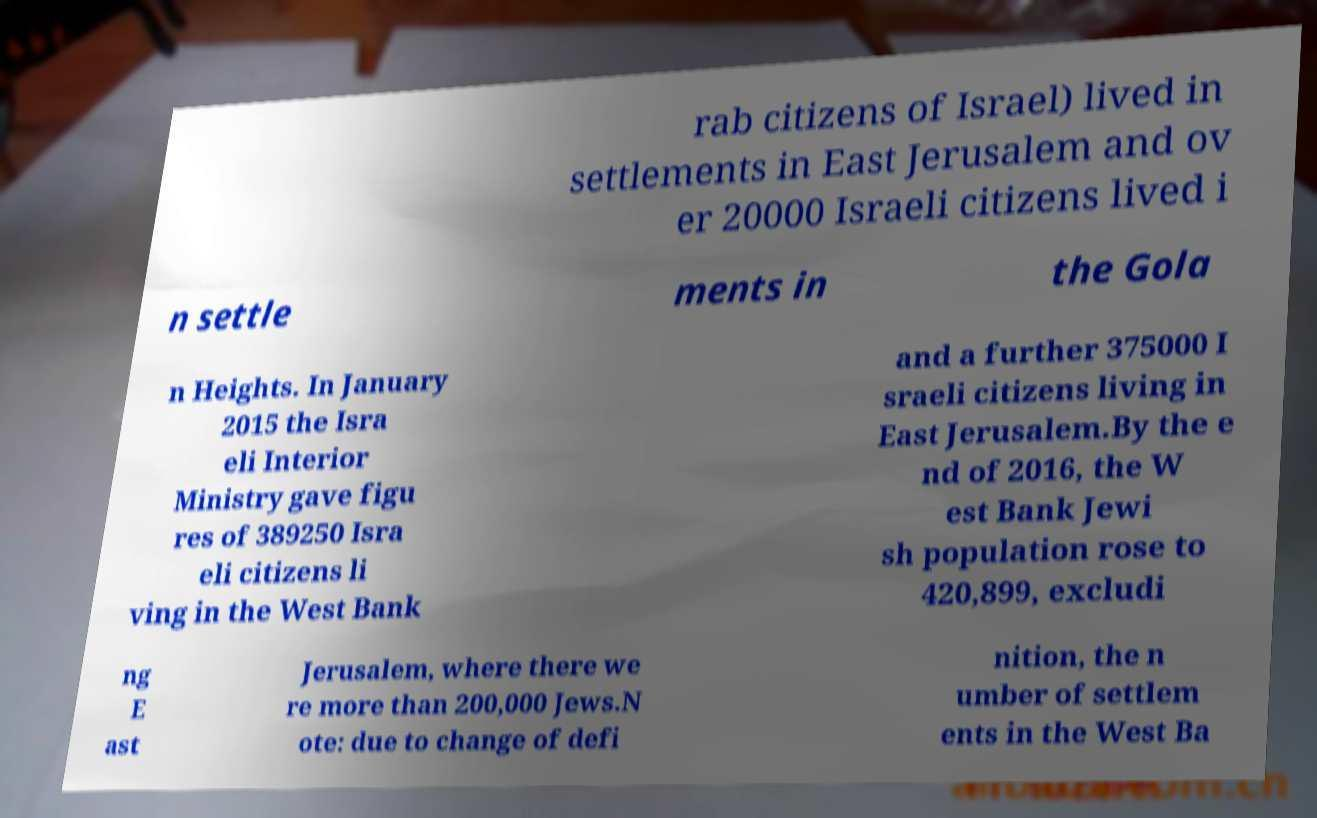Could you extract and type out the text from this image? rab citizens of Israel) lived in settlements in East Jerusalem and ov er 20000 Israeli citizens lived i n settle ments in the Gola n Heights. In January 2015 the Isra eli Interior Ministry gave figu res of 389250 Isra eli citizens li ving in the West Bank and a further 375000 I sraeli citizens living in East Jerusalem.By the e nd of 2016, the W est Bank Jewi sh population rose to 420,899, excludi ng E ast Jerusalem, where there we re more than 200,000 Jews.N ote: due to change of defi nition, the n umber of settlem ents in the West Ba 